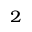Convert formula to latex. <formula><loc_0><loc_0><loc_500><loc_500>_ { 2 }</formula> 